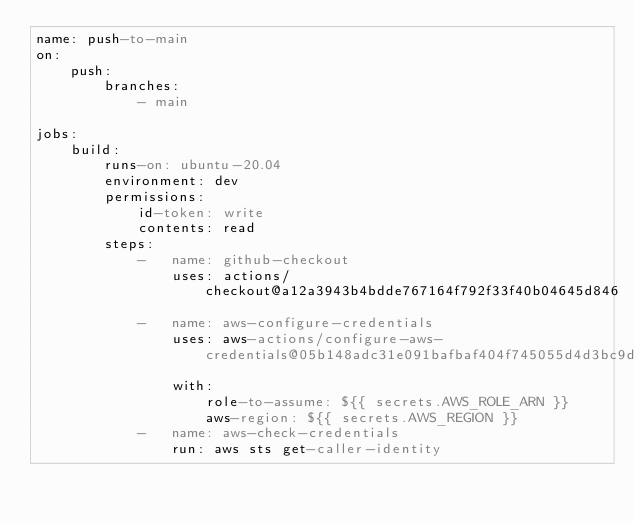<code> <loc_0><loc_0><loc_500><loc_500><_YAML_>name: push-to-main
on:
    push:
        branches:
            - main

jobs:
    build:
        runs-on: ubuntu-20.04
        environment: dev
        permissions:
            id-token: write
            contents: read
        steps:
            -   name: github-checkout
                uses: actions/checkout@a12a3943b4bdde767164f792f33f40b04645d846
            -   name: aws-configure-credentials
                uses: aws-actions/configure-aws-credentials@05b148adc31e091bafbaf404f745055d4d3bc9d2
                with:
                    role-to-assume: ${{ secrets.AWS_ROLE_ARN }}
                    aws-region: ${{ secrets.AWS_REGION }}
            -   name: aws-check-credentials
                run: aws sts get-caller-identity
</code> 